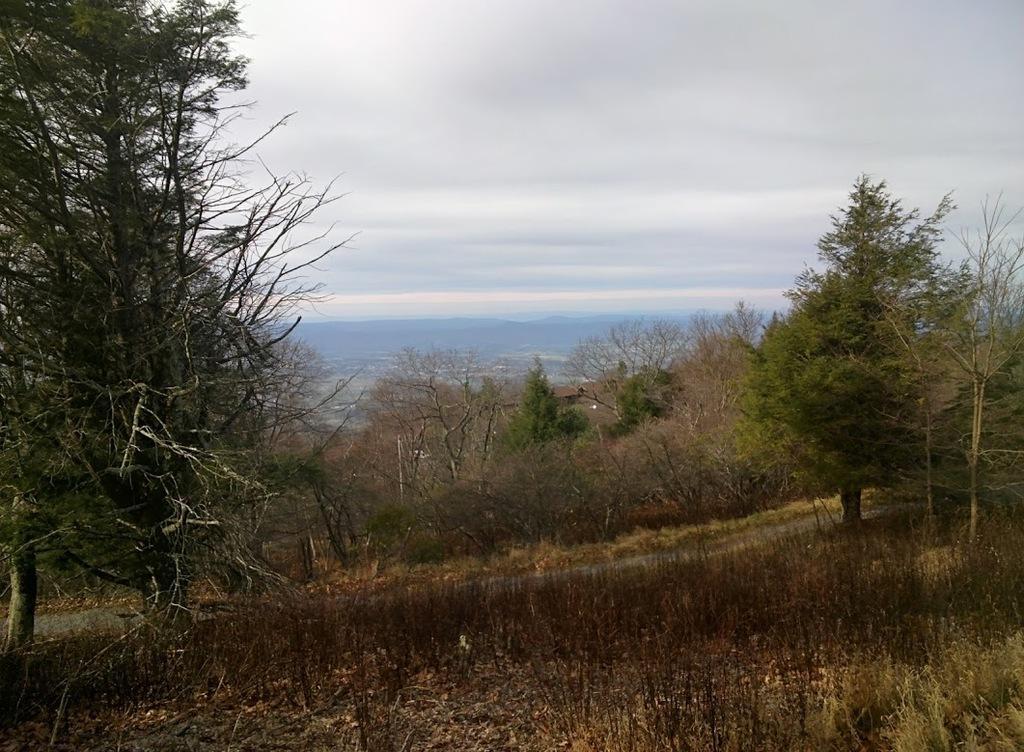Could you give a brief overview of what you see in this image? In this image we can see road, grass, trees and sky with clouds. 